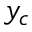<formula> <loc_0><loc_0><loc_500><loc_500>y _ { c }</formula> 